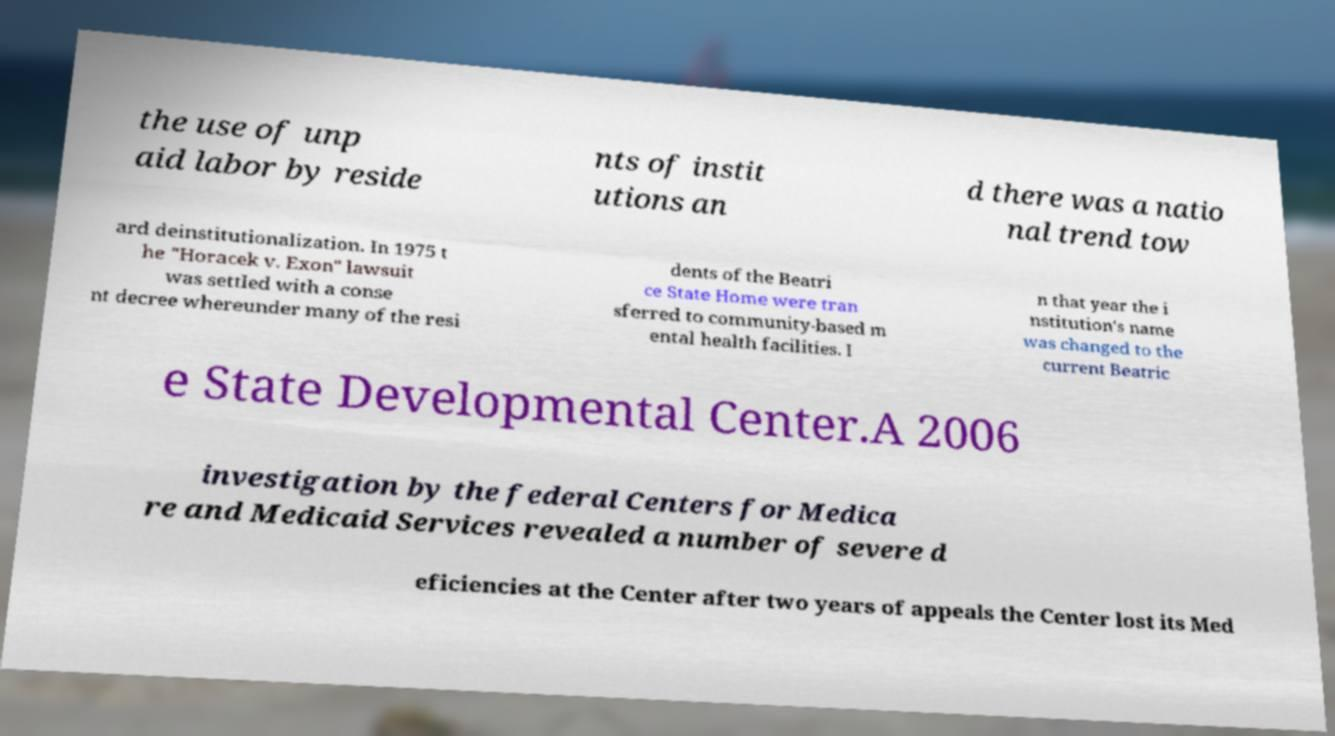Can you accurately transcribe the text from the provided image for me? the use of unp aid labor by reside nts of instit utions an d there was a natio nal trend tow ard deinstitutionalization. In 1975 t he "Horacek v. Exon" lawsuit was settled with a conse nt decree whereunder many of the resi dents of the Beatri ce State Home were tran sferred to community-based m ental health facilities. I n that year the i nstitution's name was changed to the current Beatric e State Developmental Center.A 2006 investigation by the federal Centers for Medica re and Medicaid Services revealed a number of severe d eficiencies at the Center after two years of appeals the Center lost its Med 